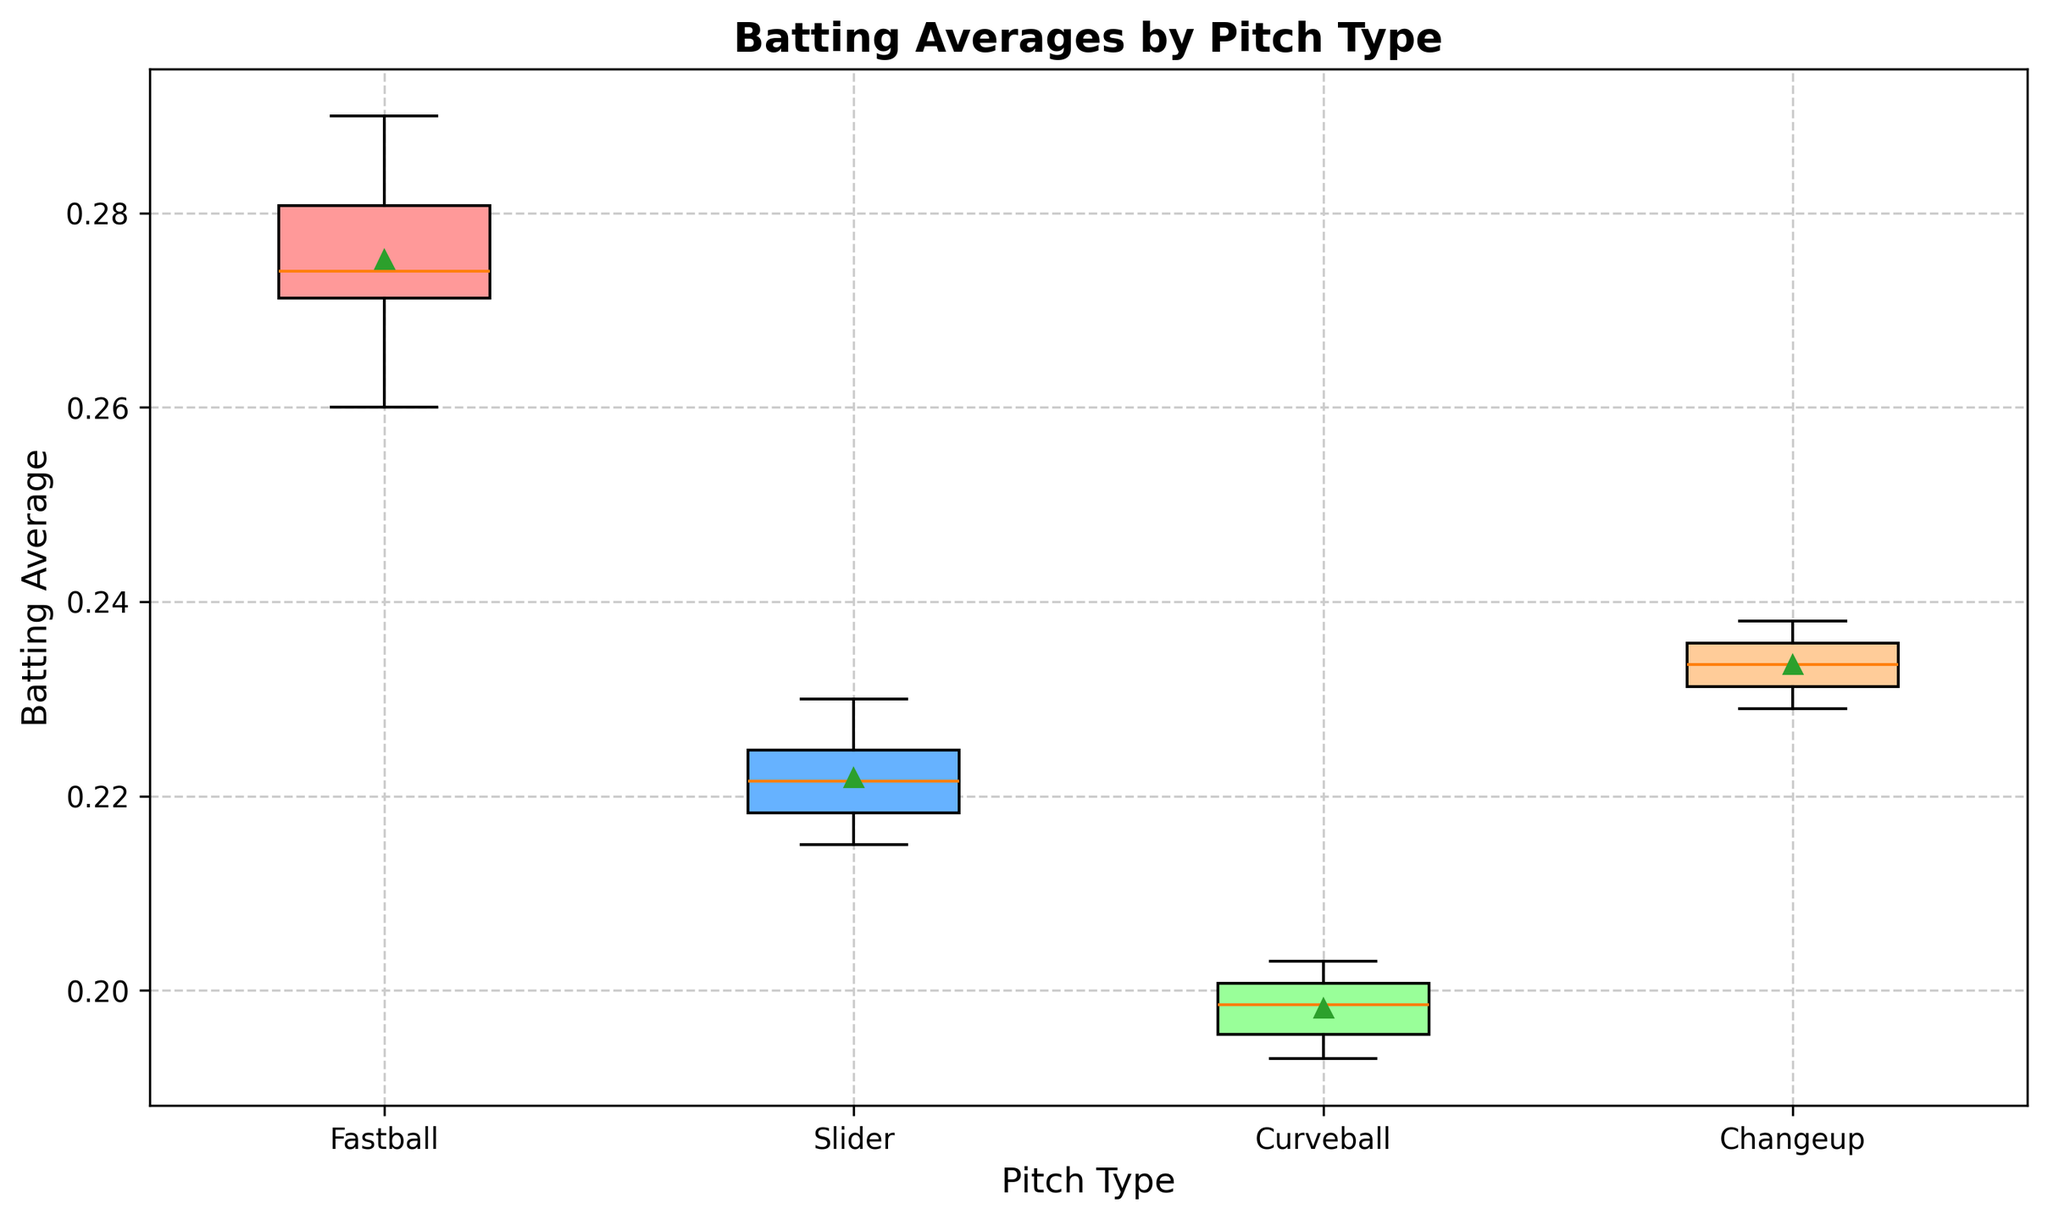What is the median batting average for Fastballs? For the Fastballs, the median value is the middle value in the ordered dataset. When the values (0.260, 0.268, 0.271, 0.272, 0.273, 0.275, 0.277, 0.282, 0.284, 0.290) are ordered, the median is (0.273+0.275)/2 = 0.274
Answer: 0.274 Which pitch type has the highest mean batting average? The box plot typically shows the mean as a specific mark like a green triangle. By observing the placement of the mean markers, Fastballs have the highest mean batting average compared to others.
Answer: Fastballs How do the interquartile ranges (IQR) of the batting averages for Fastballs and Changeups compare? The IQR is the range between the first quartile (Q1) and the third quartile (Q3). Observing the box heights, the IQR for Fastballs is wider than for Changeups, indicating more variability.
Answer: Fastballs have a wider IQR What is the range of batting averages for Curveballs? The range is the difference between the maximum and minimum values. Based on the whiskers of the box plot for Curveballs, the range is approximately from 0.193 to 0.203.
Answer: 0.010 Which pitch type exhibits the smallest variance in batting averages? The variance is visually indicated by the width of the boxes and length of whiskers. Slider appears to have the smallest variance as its box and whiskers are relatively shorter than others.
Answer: Sliders Identify the color corresponding to the highest mean batting average. The box plot color for Fastballs, which has the highest mean batting average as observed earlier, is identified. Fastballs are represented by a red-colored box.
Answer: Red Which pitch type's median is closest to its respective mean? Observing the overlap between the median line inside the box and the mean marker, the Changeups seem to have the median closely aligned with the mean compared to other pitch types.
Answer: Changeups Quantify the difference in median batting averages between Fastballs and Curveballs. The median for Fastballs was found to be 0.274 and for Curveballs approximately 0.198. The difference is thus 0.274 - 0.198 = 0.076.
Answer: 0.076 How do the median batting averages for Sliders and Changeups compare? By looking at the median lines inside the boxes, Sliders have a lower median batting average than Changeups.
Answer: Changeups have a higher median Which pitch type shows more consistency in batting performance, as indicated by a narrower box in the plot? Consistency in performance is indicated by narrower boxes (or smaller IQR). Therefore, Sliders, which have the narrowest box, show the most consistency.
Answer: Sliders 